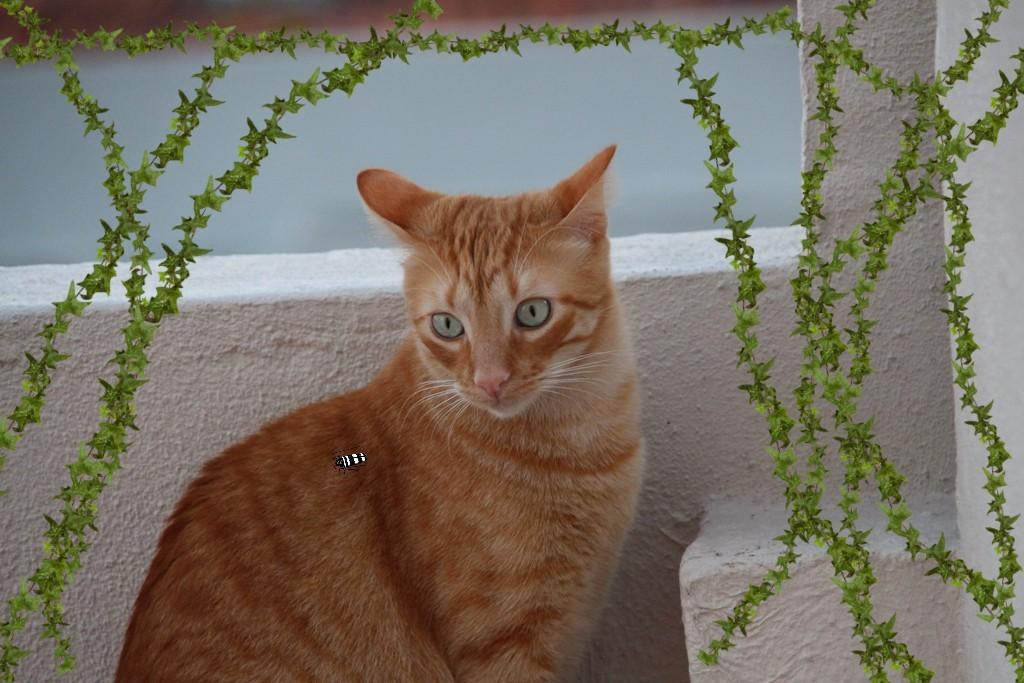What animal is sitting in the image? There is a cat sitting in the image. What is on the cat in the image? There is a fly on the cat. What is behind the cat in the image? There is a wall behind the cat. What type of vegetation is near the wall in the image? There are creepers near the wall. What nation is the woman from in the image? There is no woman present in the image, only a cat, a fly, a wall, and creepers. 